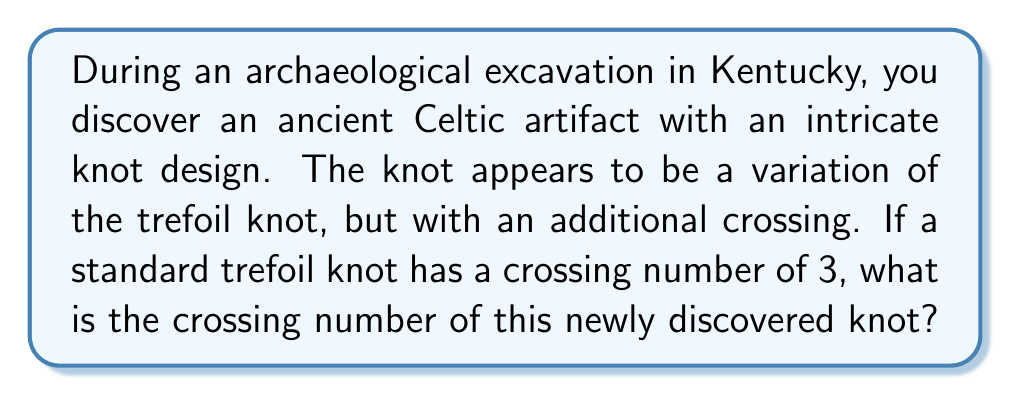Give your solution to this math problem. Let's approach this step-by-step:

1. Recall that the trefoil knot is the simplest non-trivial knot, with a crossing number of 3.

2. The crossing number of a knot is defined as the minimum number of crossings in any diagram of the knot.

3. In this case, we're told that the discovered knot is a variation of the trefoil knot with an additional crossing.

4. Mathematically, we can express this as:

   $$C_{new} = C_{trefoil} + 1$$

   Where $C_{new}$ is the crossing number of the new knot, and $C_{trefoil}$ is the crossing number of the trefoil knot.

5. We know that $C_{trefoil} = 3$, so we can substitute this:

   $$C_{new} = 3 + 1 = 4$$

6. It's important to note that this assumes the additional crossing is essential and cannot be removed through any manipulation of the knot.

7. In knot theory, this new knot with 4 crossings is known as the figure-eight knot, which is the unique prime knot with 4 crossings.

[asy]
import graph;
size(100);
path p = (0,0)..(1,1)..(0,2)..(-1,1)..(0,0);
path q = rotate(90)*p;
draw(p);
draw(q);
[/asy]

This diagram illustrates a figure-eight knot, which has 4 crossings.
Answer: 4 